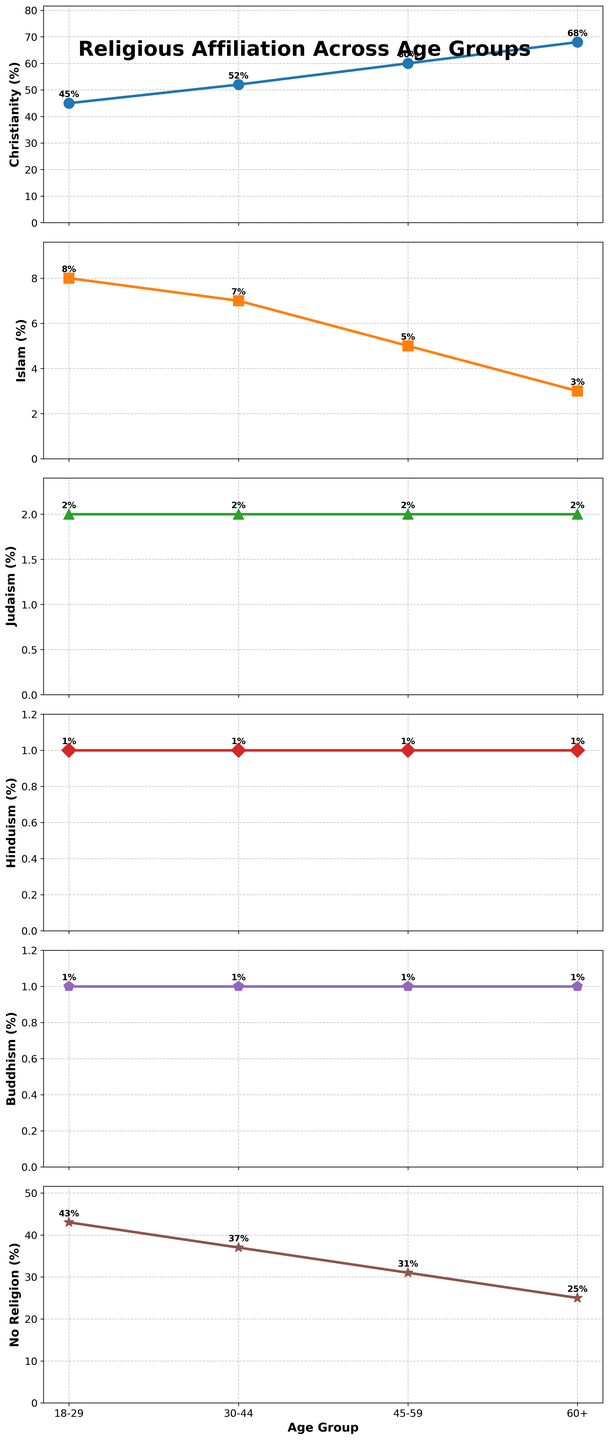What's the trend in religious affiliation with age for Christianity? Across the vertical subplots, Christianity shows an increasing trend with age. This is observable as the percentage for each age group rises from 45% (18-29), 52% (30-44), 60% (45-59), to 68% (60+).
Answer: Increasing with age Compare the percentage of "No Religion" between the 18-29 and 60+ age groups. From the subplots, the percentage of "No Religion" for 18-29 is 43%, while for 60+, it is 25%. 43% is greater than 25%.
Answer: 43% is greater Which religious affiliation shows the least variation across age groups? By examining each subplot's range, Judaism shows the least variation with percentages consistently staying at 2% across all age groups.
Answer: Judaism How does the proportion of Islam change from the youngest (18-29) to the oldest (60+) age group? The subplot for Islam indicates a decrease from 8% in the 18-29 age group to 3% in the 60+ age group, showing a decreasing trend as age increases.
Answer: Decreasing with age Calculate the average percentage of Buddhism across all age groups. Summing the percentages for Buddhism across all age groups (1+1+1+1=4) and dividing by the number of age groups (4) results in 4/4 = 1%.
Answer: 1% What is the difference in percentage points for Christianity between the 30-44 and 45-59 age groups? The subplot indicates Christianity at 52% for 30-44 and 60% for 45-59. The difference is 60% - 52% = 8 percentage points.
Answer: 8 percentage points Which age group has the highest proportion of people with no religious affiliation? The "No Religion" subplot shows that the highest percentage is 43%, seen in the 18-29 age group.
Answer: 18-29 Sum the percentages of all religious affiliations for the 45-59 age group. Summing the values for 45-59: Christianity (60) + Islam (5) + Judaism (2) + Hinduism (1) + Buddhism (1) + No Religion (31) gives 60 + 5 + 2 + 1 + 1 + 31 = 100%.
Answer: 100% Which color corresponds to the plot for Hinduism across the age groups? Referring to the visual attributes of the subplots, Hinduism is represented by a distinct red color.
Answer: Red Find the age group where the difference between Christianity and "No Religion" is the smallest. By calculating the differences: (Christianity - No Religion): 18-29 (45-43=2), 30-44 (52-37=15), 45-59 (60-31=29), 60+ (68-25=43). The smallest difference is 2, occurring in the 18-29 age group.
Answer: 18-29 